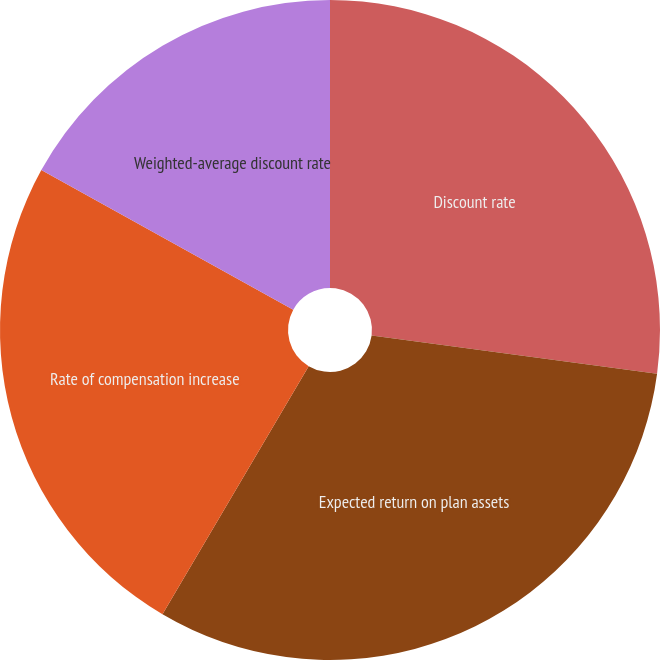Convert chart. <chart><loc_0><loc_0><loc_500><loc_500><pie_chart><fcel>Discount rate<fcel>Expected return on plan assets<fcel>Rate of compensation increase<fcel>Weighted-average discount rate<nl><fcel>27.12%<fcel>31.36%<fcel>24.58%<fcel>16.95%<nl></chart> 